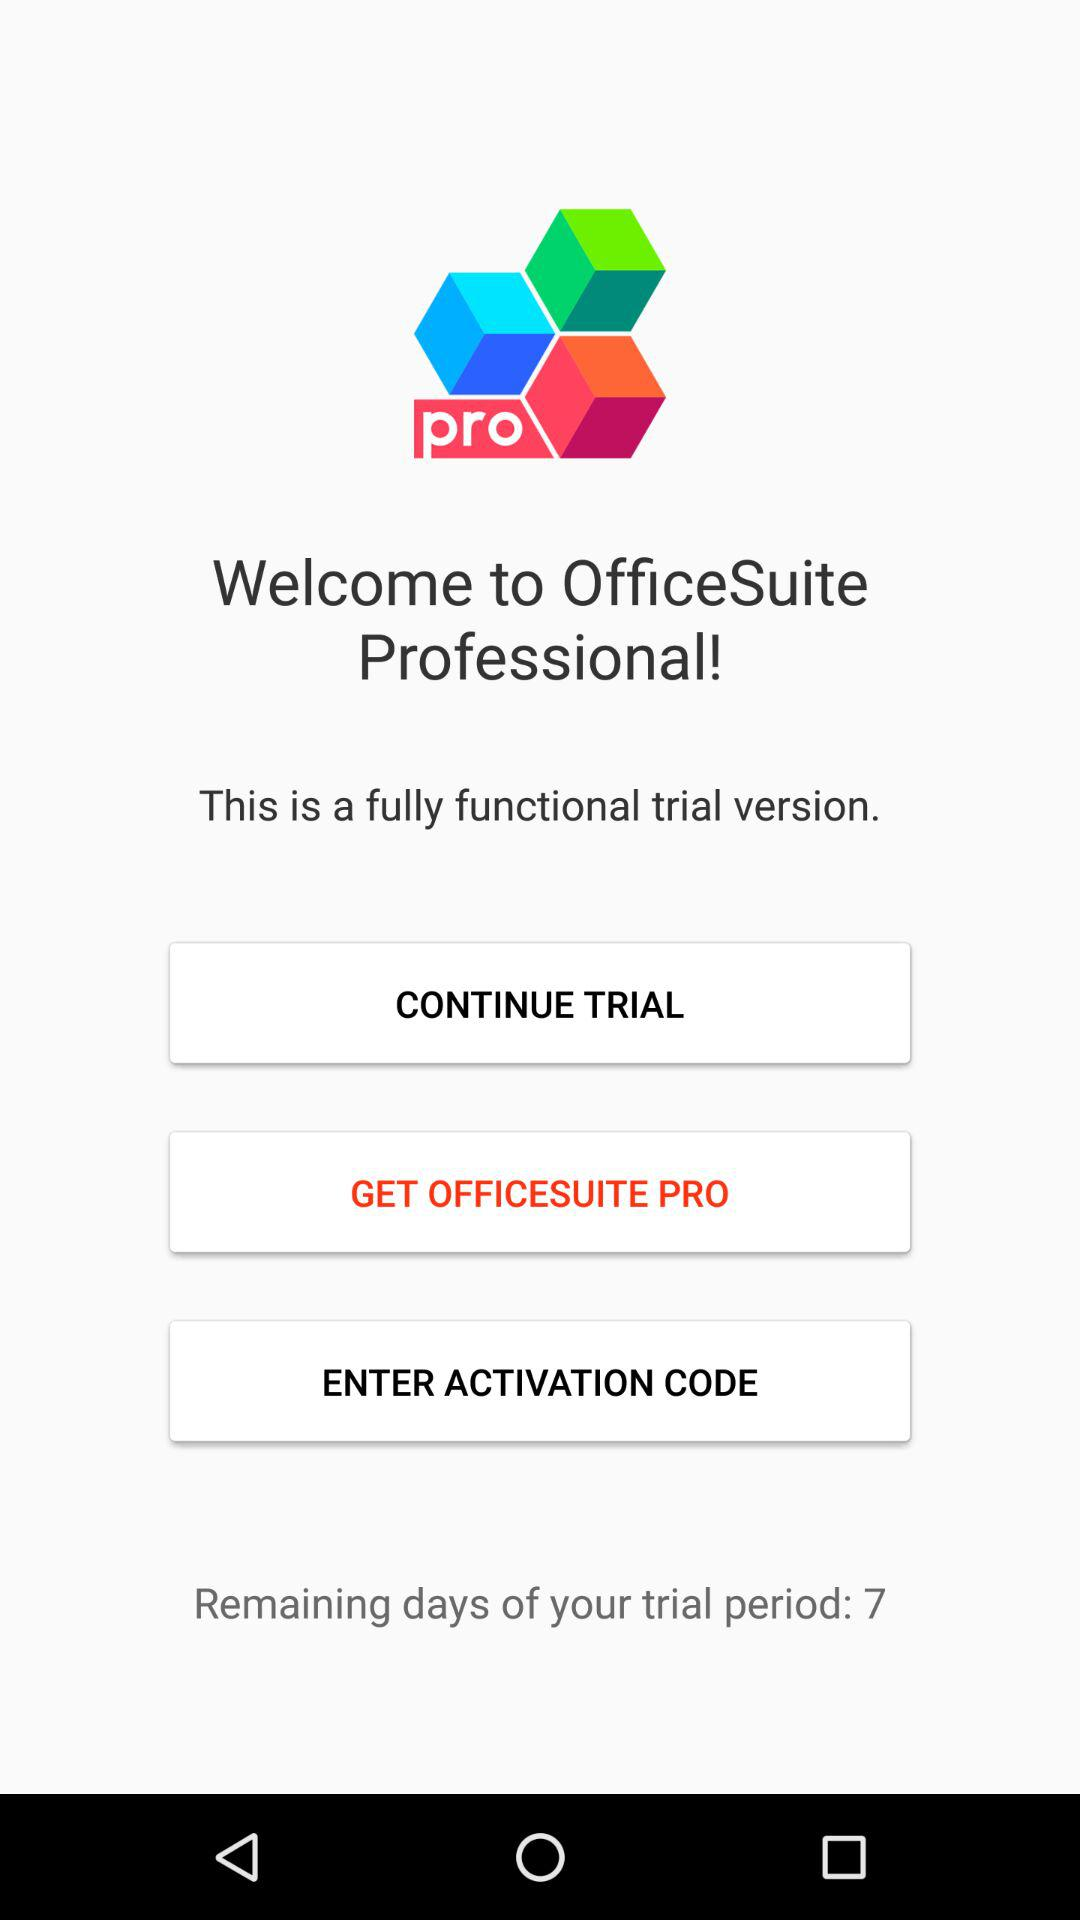What is the application name? The application name is "OfficeSuite Professional". 